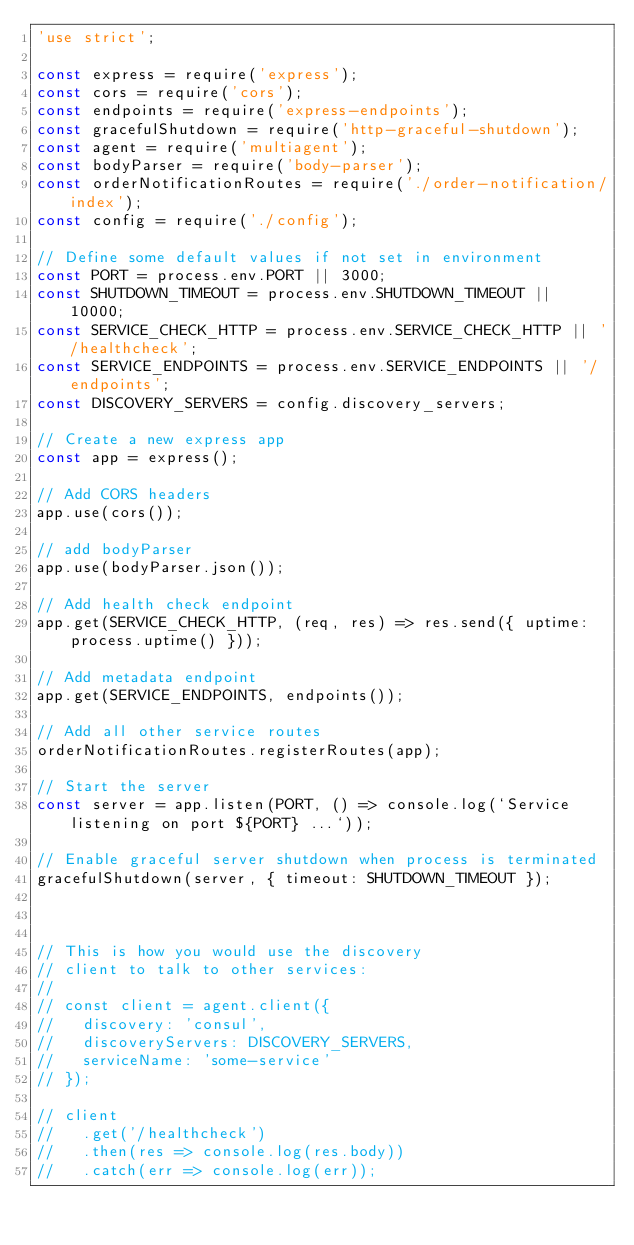Convert code to text. <code><loc_0><loc_0><loc_500><loc_500><_JavaScript_>'use strict';

const express = require('express');
const cors = require('cors');
const endpoints = require('express-endpoints');
const gracefulShutdown = require('http-graceful-shutdown');
const agent = require('multiagent');
const bodyParser = require('body-parser');
const orderNotificationRoutes = require('./order-notification/index');
const config = require('./config');

// Define some default values if not set in environment
const PORT = process.env.PORT || 3000;
const SHUTDOWN_TIMEOUT = process.env.SHUTDOWN_TIMEOUT || 10000;
const SERVICE_CHECK_HTTP = process.env.SERVICE_CHECK_HTTP || '/healthcheck';
const SERVICE_ENDPOINTS = process.env.SERVICE_ENDPOINTS || '/endpoints';
const DISCOVERY_SERVERS = config.discovery_servers;

// Create a new express app
const app = express();

// Add CORS headers
app.use(cors());

// add bodyParser
app.use(bodyParser.json());

// Add health check endpoint
app.get(SERVICE_CHECK_HTTP, (req, res) => res.send({ uptime: process.uptime() }));

// Add metadata endpoint
app.get(SERVICE_ENDPOINTS, endpoints());

// Add all other service routes
orderNotificationRoutes.registerRoutes(app);

// Start the server
const server = app.listen(PORT, () => console.log(`Service listening on port ${PORT} ...`));

// Enable graceful server shutdown when process is terminated
gracefulShutdown(server, { timeout: SHUTDOWN_TIMEOUT });



// This is how you would use the discovery
// client to talk to other services:
//
// const client = agent.client({
//   discovery: 'consul',
//   discoveryServers: DISCOVERY_SERVERS,
//   serviceName: 'some-service'
// });

// client
//   .get('/healthcheck')
//   .then(res => console.log(res.body))
//   .catch(err => console.log(err));
</code> 